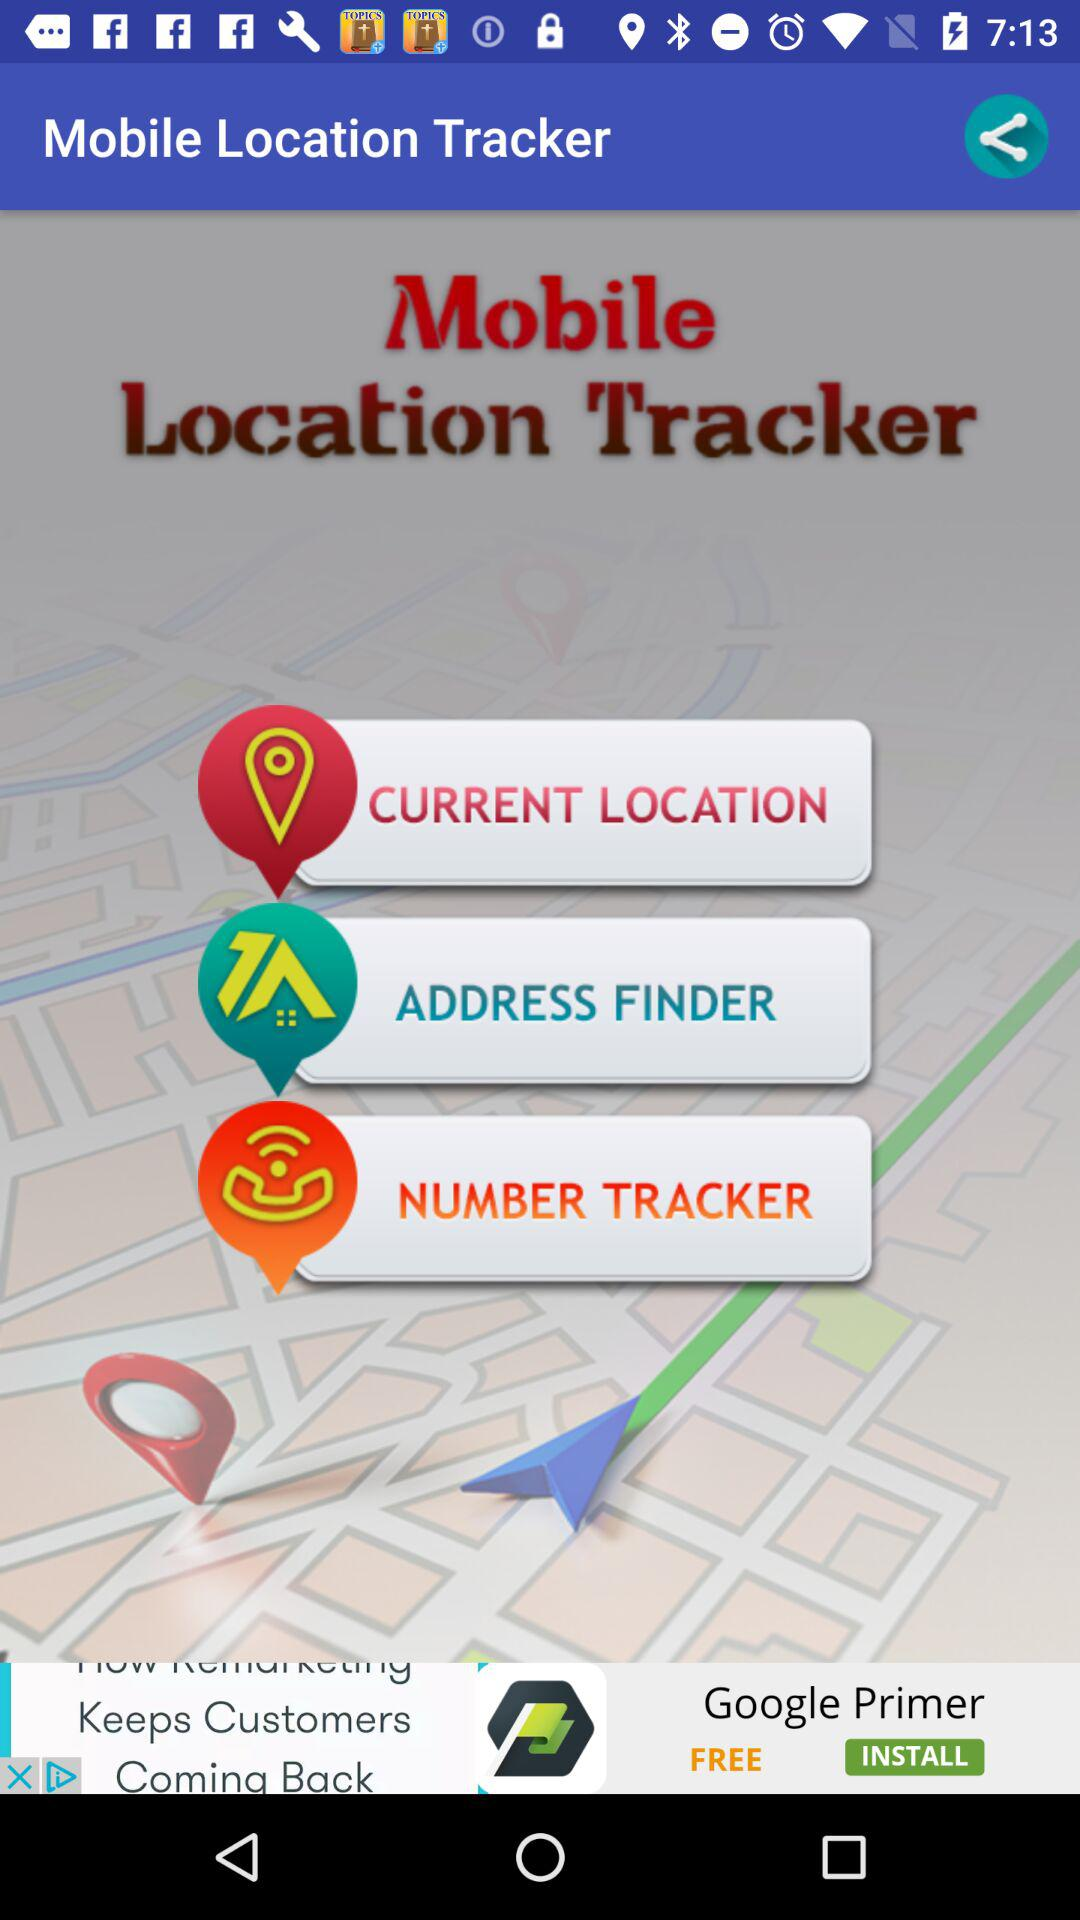What is the name of the application? The name of the application is "Mobile Location Tracker". 